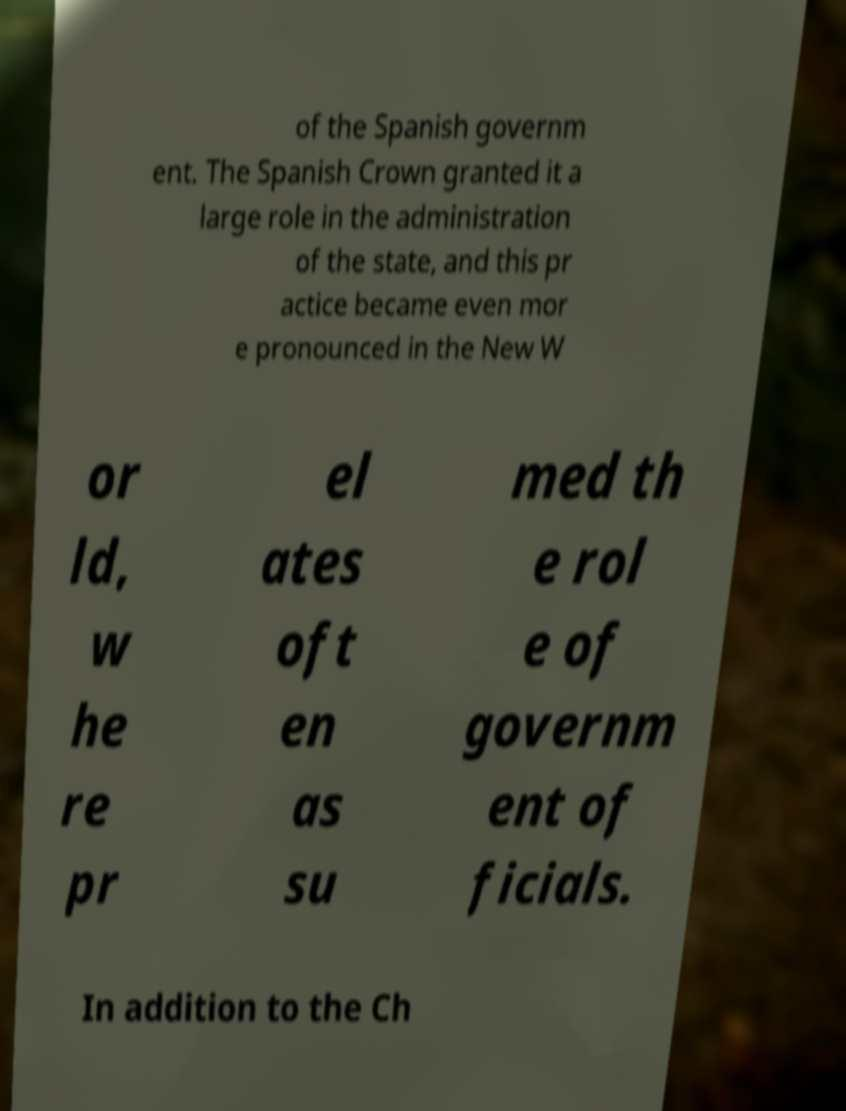Could you assist in decoding the text presented in this image and type it out clearly? of the Spanish governm ent. The Spanish Crown granted it a large role in the administration of the state, and this pr actice became even mor e pronounced in the New W or ld, w he re pr el ates oft en as su med th e rol e of governm ent of ficials. In addition to the Ch 